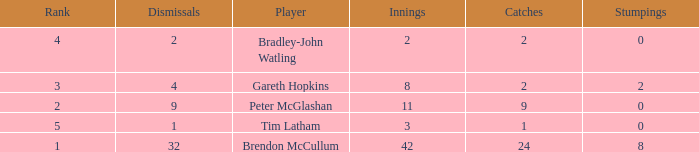How many dismissals did the player Peter McGlashan have? 9.0. Can you give me this table as a dict? {'header': ['Rank', 'Dismissals', 'Player', 'Innings', 'Catches', 'Stumpings'], 'rows': [['4', '2', 'Bradley-John Watling', '2', '2', '0'], ['3', '4', 'Gareth Hopkins', '8', '2', '2'], ['2', '9', 'Peter McGlashan', '11', '9', '0'], ['5', '1', 'Tim Latham', '3', '1', '0'], ['1', '32', 'Brendon McCullum', '42', '24', '8']]} 